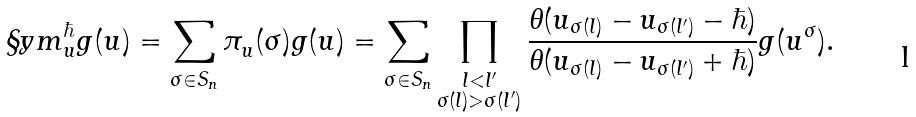Convert formula to latex. <formula><loc_0><loc_0><loc_500><loc_500>\S y m ^ { \hbar } _ { u } g ( u ) = \sum _ { \sigma \in S _ { n } } \pi ^ { } _ { u } ( \sigma ) g ( u ) = \sum _ { \sigma \in S _ { n } } \prod _ { \substack { l < l ^ { \prime } \\ \sigma ( l ) > \sigma ( l ^ { \prime } ) } } \frac { \theta ( u _ { \sigma ( l ) } - u _ { \sigma ( l ^ { \prime } ) } - \hbar { ) } } { \theta ( u _ { \sigma ( l ) } - u _ { \sigma ( l ^ { \prime } ) } + \hbar { ) } } g ( u ^ { \sigma } ) .</formula> 